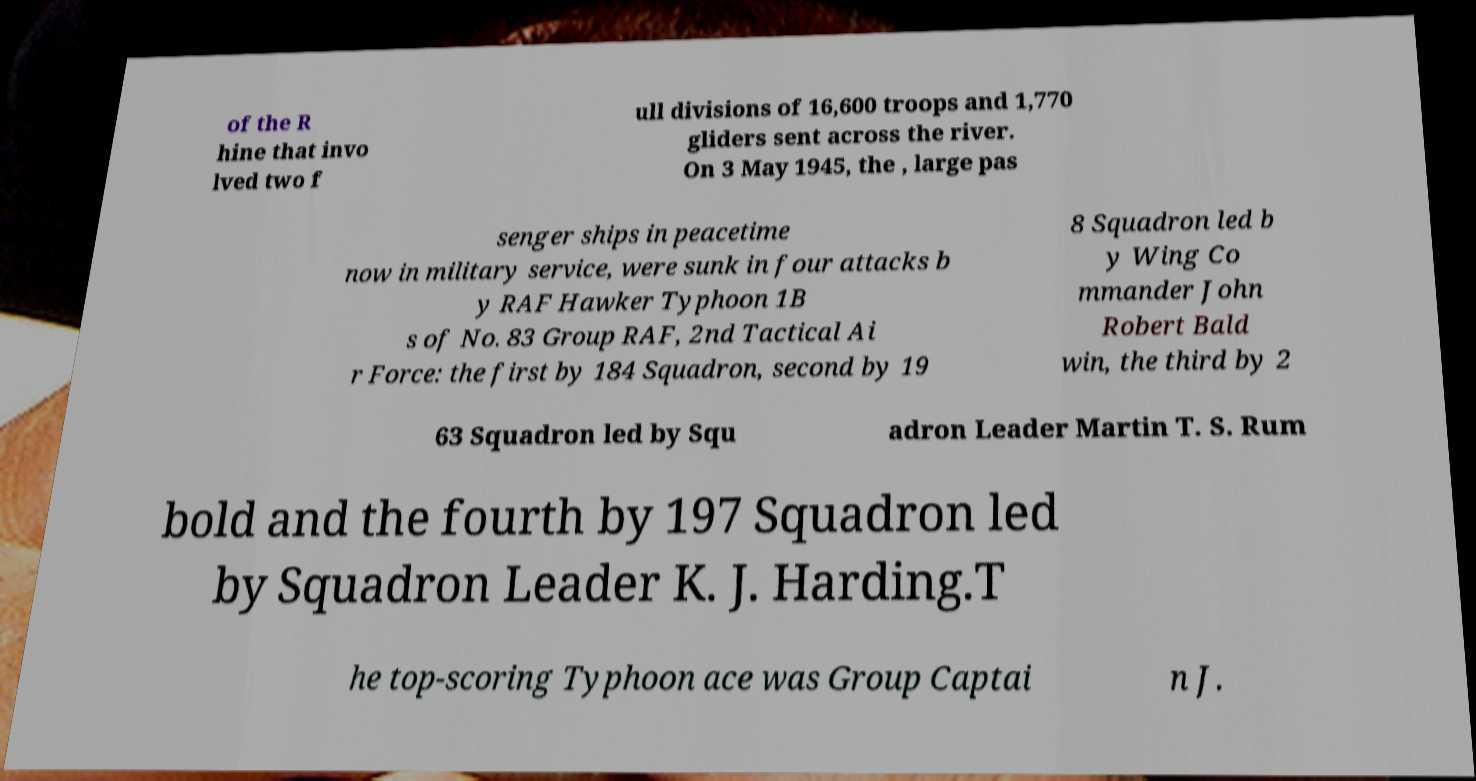There's text embedded in this image that I need extracted. Can you transcribe it verbatim? of the R hine that invo lved two f ull divisions of 16,600 troops and 1,770 gliders sent across the river. On 3 May 1945, the , large pas senger ships in peacetime now in military service, were sunk in four attacks b y RAF Hawker Typhoon 1B s of No. 83 Group RAF, 2nd Tactical Ai r Force: the first by 184 Squadron, second by 19 8 Squadron led b y Wing Co mmander John Robert Bald win, the third by 2 63 Squadron led by Squ adron Leader Martin T. S. Rum bold and the fourth by 197 Squadron led by Squadron Leader K. J. Harding.T he top-scoring Typhoon ace was Group Captai n J. 